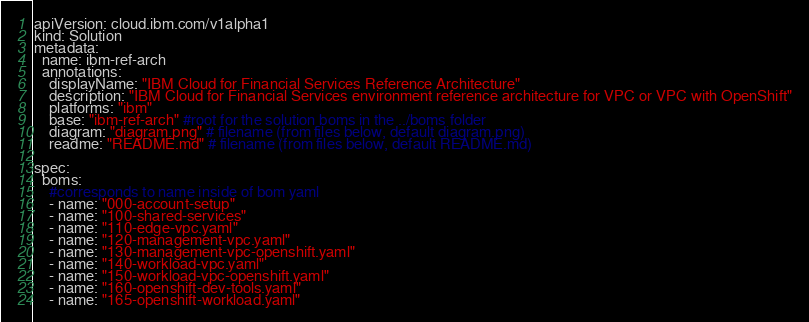Convert code to text. <code><loc_0><loc_0><loc_500><loc_500><_YAML_>apiVersion: cloud.ibm.com/v1alpha1
kind: Solution
metadata:
  name: ibm-ref-arch
  annotations:
    displayName: "IBM Cloud for Financial Services Reference Architecture"
    description: "IBM Cloud for Financial Services environment reference architecture for VPC or VPC with OpenShift"
    platforms: "ibm"
    base: "ibm-ref-arch" #root for the solution boms in the ../boms folder
    diagram: "diagram.png" # filename (from files below, default diagram.png)
    readme: "README.md" # filename (from files below, default README.md)

spec:
  boms:
    #corresponds to name inside of bom yaml
    - name: "000-account-setup"   
    - name: "100-shared-services"
    - name: "110-edge-vpc.yaml" 
    - name: "120-management-vpc.yaml"
    - name: "130-management-vpc-openshift.yaml"
    - name: "140-workload-vpc.yaml"
    - name: "150-workload-vpc-openshift.yaml"
    - name: "160-openshift-dev-tools.yaml"
    - name: "165-openshift-workload.yaml"</code> 